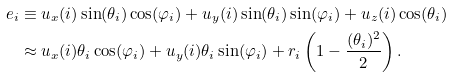<formula> <loc_0><loc_0><loc_500><loc_500>e _ { i } & \equiv u _ { x } ( i ) \sin ( \theta _ { i } ) \cos ( \varphi _ { i } ) + u _ { y } ( i ) \sin ( \theta _ { i } ) \sin ( \varphi _ { i } ) + u _ { z } ( i ) \cos ( \theta _ { i } ) \\ & \approx u _ { x } ( i ) \theta _ { i } \cos ( \varphi _ { i } ) + u _ { y } ( i ) \theta _ { i } \sin ( \varphi _ { i } ) + r _ { i } \left ( 1 - \frac { ( \theta _ { i } ) ^ { 2 } } { 2 } \right ) .</formula> 